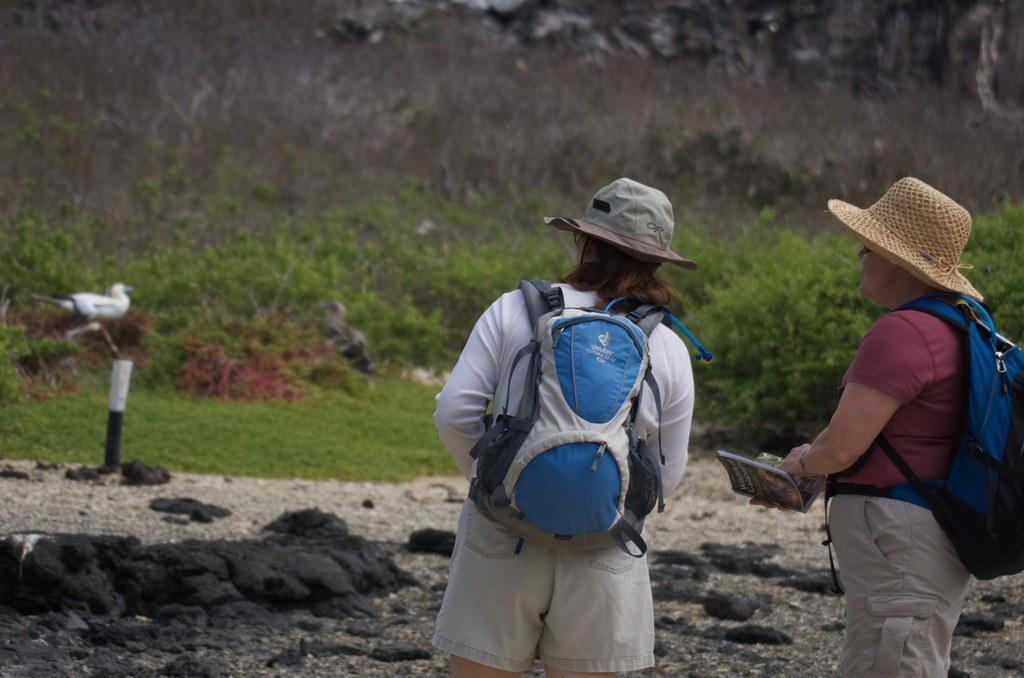Describe this image in one or two sentences. In this image we can see one bird, one pole, some rocks on the ground, some plants with flowers, one person holding a book on the right side of the image, some objects in the background, the background is blurred, some trees, bushes, plants and grass on the ground. There are two persons with hats, wearing backpacks and standing. 